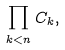<formula> <loc_0><loc_0><loc_500><loc_500>\prod _ { k < n } { C _ { k } } ,</formula> 